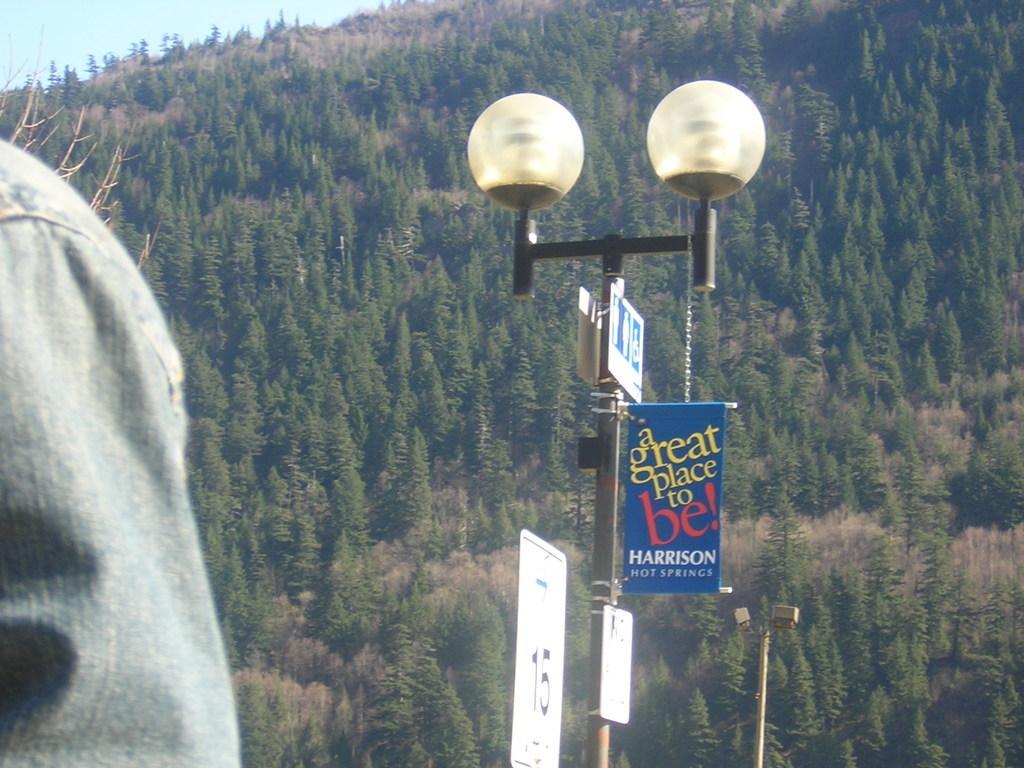Could you give a brief overview of what you see in this image? In the picture I can see the decorative light pole. I can see a banner on the pole. It is looking like an LED hoarding board at the bottom of the picture. I can see the hand of a person on the left side. In the background, I can see the trees. 